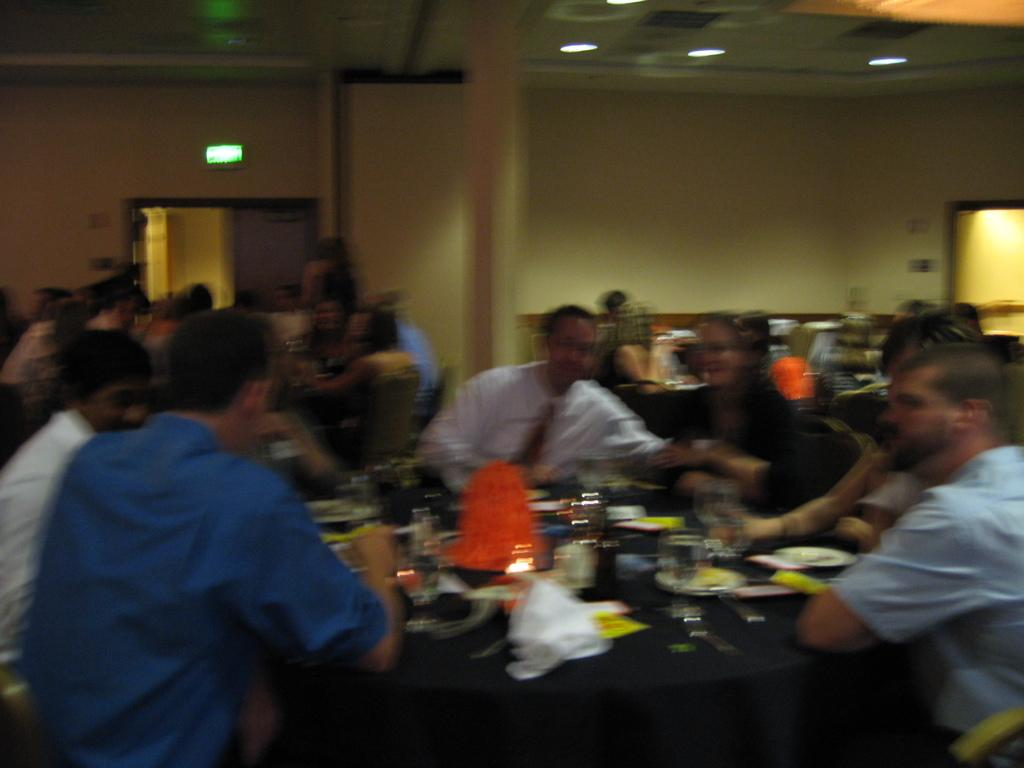How many people are in the image? There is a group of people in the image, but the exact number cannot be determined from the provided facts. What is on the table in the image? There are plates, glasses, and other objects on the table in the image. What can be seen in the background of the image? There is a wall, a pillar, a mirror, and lights in the background of the image. Can you describe the cave in the image? There is no cave present in the image; it features a group of people, a table, and various objects, as well as a background with a wall, a pillar, a mirror, and lights. 